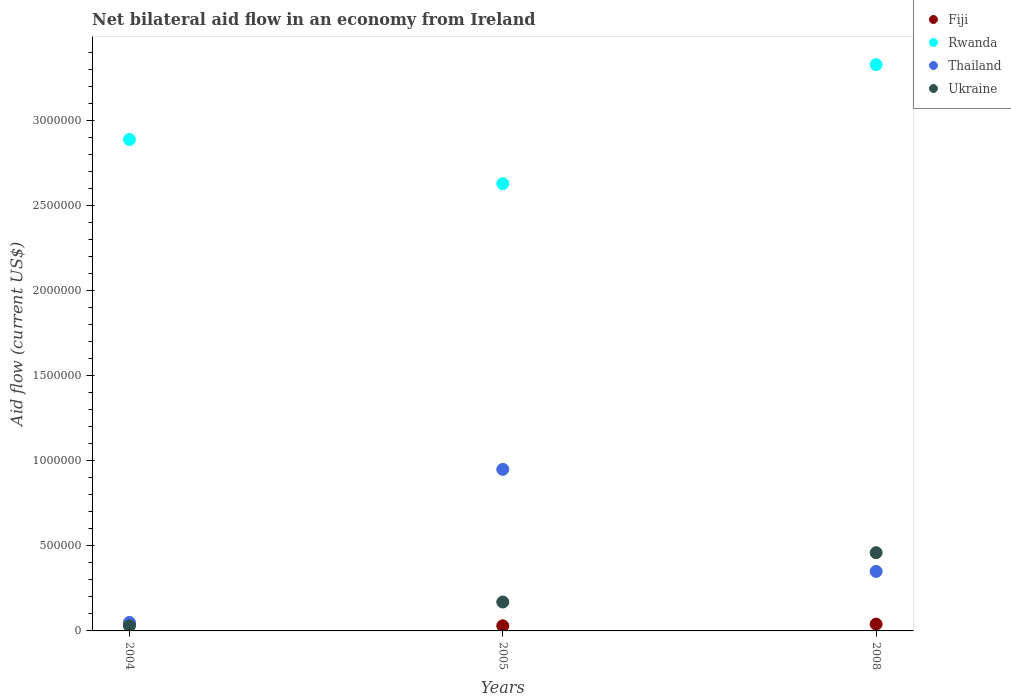How many different coloured dotlines are there?
Provide a short and direct response. 4. Is the number of dotlines equal to the number of legend labels?
Your response must be concise. Yes. What is the net bilateral aid flow in Fiji in 2004?
Provide a short and direct response. 4.00e+04. Across all years, what is the maximum net bilateral aid flow in Thailand?
Provide a succinct answer. 9.50e+05. Across all years, what is the minimum net bilateral aid flow in Rwanda?
Keep it short and to the point. 2.63e+06. In which year was the net bilateral aid flow in Fiji minimum?
Make the answer very short. 2005. What is the difference between the net bilateral aid flow in Rwanda in 2004 and that in 2008?
Offer a very short reply. -4.40e+05. What is the difference between the net bilateral aid flow in Ukraine in 2004 and the net bilateral aid flow in Rwanda in 2008?
Your answer should be very brief. -3.30e+06. What is the average net bilateral aid flow in Ukraine per year?
Offer a terse response. 2.20e+05. In the year 2008, what is the difference between the net bilateral aid flow in Fiji and net bilateral aid flow in Ukraine?
Keep it short and to the point. -4.20e+05. What is the ratio of the net bilateral aid flow in Rwanda in 2004 to that in 2008?
Give a very brief answer. 0.87. Is the difference between the net bilateral aid flow in Fiji in 2004 and 2005 greater than the difference between the net bilateral aid flow in Ukraine in 2004 and 2005?
Your response must be concise. Yes. What is the difference between the highest and the second highest net bilateral aid flow in Fiji?
Provide a succinct answer. 0. What is the difference between the highest and the lowest net bilateral aid flow in Rwanda?
Provide a short and direct response. 7.00e+05. In how many years, is the net bilateral aid flow in Thailand greater than the average net bilateral aid flow in Thailand taken over all years?
Your response must be concise. 1. Is it the case that in every year, the sum of the net bilateral aid flow in Rwanda and net bilateral aid flow in Ukraine  is greater than the sum of net bilateral aid flow in Thailand and net bilateral aid flow in Fiji?
Your answer should be compact. Yes. Is it the case that in every year, the sum of the net bilateral aid flow in Thailand and net bilateral aid flow in Rwanda  is greater than the net bilateral aid flow in Ukraine?
Offer a very short reply. Yes. Does the net bilateral aid flow in Fiji monotonically increase over the years?
Provide a short and direct response. No. Is the net bilateral aid flow in Thailand strictly greater than the net bilateral aid flow in Fiji over the years?
Offer a very short reply. Yes. How many years are there in the graph?
Your answer should be very brief. 3. Does the graph contain any zero values?
Offer a terse response. No. Does the graph contain grids?
Offer a terse response. No. How many legend labels are there?
Ensure brevity in your answer.  4. What is the title of the graph?
Provide a short and direct response. Net bilateral aid flow in an economy from Ireland. Does "Mozambique" appear as one of the legend labels in the graph?
Provide a short and direct response. No. What is the label or title of the Y-axis?
Your answer should be compact. Aid flow (current US$). What is the Aid flow (current US$) of Rwanda in 2004?
Provide a short and direct response. 2.89e+06. What is the Aid flow (current US$) of Ukraine in 2004?
Offer a very short reply. 3.00e+04. What is the Aid flow (current US$) in Fiji in 2005?
Your answer should be very brief. 3.00e+04. What is the Aid flow (current US$) of Rwanda in 2005?
Your response must be concise. 2.63e+06. What is the Aid flow (current US$) of Thailand in 2005?
Offer a terse response. 9.50e+05. What is the Aid flow (current US$) in Ukraine in 2005?
Your answer should be very brief. 1.70e+05. What is the Aid flow (current US$) in Rwanda in 2008?
Offer a terse response. 3.33e+06. What is the Aid flow (current US$) in Ukraine in 2008?
Offer a terse response. 4.60e+05. Across all years, what is the maximum Aid flow (current US$) in Fiji?
Provide a succinct answer. 4.00e+04. Across all years, what is the maximum Aid flow (current US$) of Rwanda?
Offer a terse response. 3.33e+06. Across all years, what is the maximum Aid flow (current US$) of Thailand?
Make the answer very short. 9.50e+05. Across all years, what is the maximum Aid flow (current US$) in Ukraine?
Your response must be concise. 4.60e+05. Across all years, what is the minimum Aid flow (current US$) of Fiji?
Offer a terse response. 3.00e+04. Across all years, what is the minimum Aid flow (current US$) of Rwanda?
Make the answer very short. 2.63e+06. What is the total Aid flow (current US$) in Rwanda in the graph?
Provide a short and direct response. 8.85e+06. What is the total Aid flow (current US$) in Thailand in the graph?
Ensure brevity in your answer.  1.35e+06. What is the difference between the Aid flow (current US$) in Rwanda in 2004 and that in 2005?
Ensure brevity in your answer.  2.60e+05. What is the difference between the Aid flow (current US$) in Thailand in 2004 and that in 2005?
Provide a succinct answer. -9.00e+05. What is the difference between the Aid flow (current US$) in Ukraine in 2004 and that in 2005?
Offer a terse response. -1.40e+05. What is the difference between the Aid flow (current US$) in Fiji in 2004 and that in 2008?
Offer a very short reply. 0. What is the difference between the Aid flow (current US$) in Rwanda in 2004 and that in 2008?
Offer a terse response. -4.40e+05. What is the difference between the Aid flow (current US$) of Thailand in 2004 and that in 2008?
Offer a very short reply. -3.00e+05. What is the difference between the Aid flow (current US$) in Ukraine in 2004 and that in 2008?
Your answer should be compact. -4.30e+05. What is the difference between the Aid flow (current US$) of Fiji in 2005 and that in 2008?
Ensure brevity in your answer.  -10000. What is the difference between the Aid flow (current US$) of Rwanda in 2005 and that in 2008?
Your answer should be compact. -7.00e+05. What is the difference between the Aid flow (current US$) of Ukraine in 2005 and that in 2008?
Your answer should be compact. -2.90e+05. What is the difference between the Aid flow (current US$) of Fiji in 2004 and the Aid flow (current US$) of Rwanda in 2005?
Offer a terse response. -2.59e+06. What is the difference between the Aid flow (current US$) of Fiji in 2004 and the Aid flow (current US$) of Thailand in 2005?
Offer a very short reply. -9.10e+05. What is the difference between the Aid flow (current US$) of Rwanda in 2004 and the Aid flow (current US$) of Thailand in 2005?
Provide a short and direct response. 1.94e+06. What is the difference between the Aid flow (current US$) of Rwanda in 2004 and the Aid flow (current US$) of Ukraine in 2005?
Offer a terse response. 2.72e+06. What is the difference between the Aid flow (current US$) in Fiji in 2004 and the Aid flow (current US$) in Rwanda in 2008?
Your answer should be compact. -3.29e+06. What is the difference between the Aid flow (current US$) in Fiji in 2004 and the Aid flow (current US$) in Thailand in 2008?
Your answer should be very brief. -3.10e+05. What is the difference between the Aid flow (current US$) in Fiji in 2004 and the Aid flow (current US$) in Ukraine in 2008?
Give a very brief answer. -4.20e+05. What is the difference between the Aid flow (current US$) of Rwanda in 2004 and the Aid flow (current US$) of Thailand in 2008?
Your response must be concise. 2.54e+06. What is the difference between the Aid flow (current US$) in Rwanda in 2004 and the Aid flow (current US$) in Ukraine in 2008?
Offer a terse response. 2.43e+06. What is the difference between the Aid flow (current US$) in Thailand in 2004 and the Aid flow (current US$) in Ukraine in 2008?
Provide a short and direct response. -4.10e+05. What is the difference between the Aid flow (current US$) of Fiji in 2005 and the Aid flow (current US$) of Rwanda in 2008?
Offer a terse response. -3.30e+06. What is the difference between the Aid flow (current US$) of Fiji in 2005 and the Aid flow (current US$) of Thailand in 2008?
Give a very brief answer. -3.20e+05. What is the difference between the Aid flow (current US$) in Fiji in 2005 and the Aid flow (current US$) in Ukraine in 2008?
Provide a succinct answer. -4.30e+05. What is the difference between the Aid flow (current US$) of Rwanda in 2005 and the Aid flow (current US$) of Thailand in 2008?
Your answer should be compact. 2.28e+06. What is the difference between the Aid flow (current US$) in Rwanda in 2005 and the Aid flow (current US$) in Ukraine in 2008?
Give a very brief answer. 2.17e+06. What is the difference between the Aid flow (current US$) in Thailand in 2005 and the Aid flow (current US$) in Ukraine in 2008?
Provide a succinct answer. 4.90e+05. What is the average Aid flow (current US$) in Fiji per year?
Make the answer very short. 3.67e+04. What is the average Aid flow (current US$) in Rwanda per year?
Offer a terse response. 2.95e+06. In the year 2004, what is the difference between the Aid flow (current US$) of Fiji and Aid flow (current US$) of Rwanda?
Ensure brevity in your answer.  -2.85e+06. In the year 2004, what is the difference between the Aid flow (current US$) in Fiji and Aid flow (current US$) in Thailand?
Make the answer very short. -10000. In the year 2004, what is the difference between the Aid flow (current US$) in Rwanda and Aid flow (current US$) in Thailand?
Keep it short and to the point. 2.84e+06. In the year 2004, what is the difference between the Aid flow (current US$) of Rwanda and Aid flow (current US$) of Ukraine?
Your answer should be compact. 2.86e+06. In the year 2005, what is the difference between the Aid flow (current US$) of Fiji and Aid flow (current US$) of Rwanda?
Your response must be concise. -2.60e+06. In the year 2005, what is the difference between the Aid flow (current US$) in Fiji and Aid flow (current US$) in Thailand?
Your answer should be very brief. -9.20e+05. In the year 2005, what is the difference between the Aid flow (current US$) of Fiji and Aid flow (current US$) of Ukraine?
Keep it short and to the point. -1.40e+05. In the year 2005, what is the difference between the Aid flow (current US$) in Rwanda and Aid flow (current US$) in Thailand?
Your response must be concise. 1.68e+06. In the year 2005, what is the difference between the Aid flow (current US$) in Rwanda and Aid flow (current US$) in Ukraine?
Your answer should be very brief. 2.46e+06. In the year 2005, what is the difference between the Aid flow (current US$) of Thailand and Aid flow (current US$) of Ukraine?
Offer a very short reply. 7.80e+05. In the year 2008, what is the difference between the Aid flow (current US$) in Fiji and Aid flow (current US$) in Rwanda?
Ensure brevity in your answer.  -3.29e+06. In the year 2008, what is the difference between the Aid flow (current US$) of Fiji and Aid flow (current US$) of Thailand?
Provide a short and direct response. -3.10e+05. In the year 2008, what is the difference between the Aid flow (current US$) of Fiji and Aid flow (current US$) of Ukraine?
Offer a very short reply. -4.20e+05. In the year 2008, what is the difference between the Aid flow (current US$) of Rwanda and Aid flow (current US$) of Thailand?
Make the answer very short. 2.98e+06. In the year 2008, what is the difference between the Aid flow (current US$) in Rwanda and Aid flow (current US$) in Ukraine?
Your response must be concise. 2.87e+06. What is the ratio of the Aid flow (current US$) in Fiji in 2004 to that in 2005?
Provide a succinct answer. 1.33. What is the ratio of the Aid flow (current US$) of Rwanda in 2004 to that in 2005?
Your answer should be compact. 1.1. What is the ratio of the Aid flow (current US$) of Thailand in 2004 to that in 2005?
Your answer should be very brief. 0.05. What is the ratio of the Aid flow (current US$) in Ukraine in 2004 to that in 2005?
Your response must be concise. 0.18. What is the ratio of the Aid flow (current US$) in Fiji in 2004 to that in 2008?
Offer a terse response. 1. What is the ratio of the Aid flow (current US$) of Rwanda in 2004 to that in 2008?
Offer a terse response. 0.87. What is the ratio of the Aid flow (current US$) of Thailand in 2004 to that in 2008?
Give a very brief answer. 0.14. What is the ratio of the Aid flow (current US$) in Ukraine in 2004 to that in 2008?
Offer a terse response. 0.07. What is the ratio of the Aid flow (current US$) in Rwanda in 2005 to that in 2008?
Your answer should be very brief. 0.79. What is the ratio of the Aid flow (current US$) of Thailand in 2005 to that in 2008?
Make the answer very short. 2.71. What is the ratio of the Aid flow (current US$) of Ukraine in 2005 to that in 2008?
Offer a terse response. 0.37. What is the difference between the highest and the second highest Aid flow (current US$) of Fiji?
Provide a short and direct response. 0. What is the difference between the highest and the second highest Aid flow (current US$) in Rwanda?
Provide a short and direct response. 4.40e+05. What is the difference between the highest and the second highest Aid flow (current US$) of Thailand?
Give a very brief answer. 6.00e+05. What is the difference between the highest and the lowest Aid flow (current US$) of Fiji?
Your answer should be compact. 10000. What is the difference between the highest and the lowest Aid flow (current US$) in Ukraine?
Offer a very short reply. 4.30e+05. 